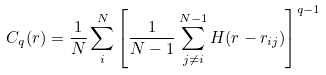Convert formula to latex. <formula><loc_0><loc_0><loc_500><loc_500>C _ { q } ( r ) = \frac { 1 } { N } \sum _ { i } ^ { N } \left [ \frac { 1 } { N - 1 } \sum _ { j \not = i } ^ { N - 1 } H ( r - r _ { i j } ) \right ] ^ { q - 1 }</formula> 